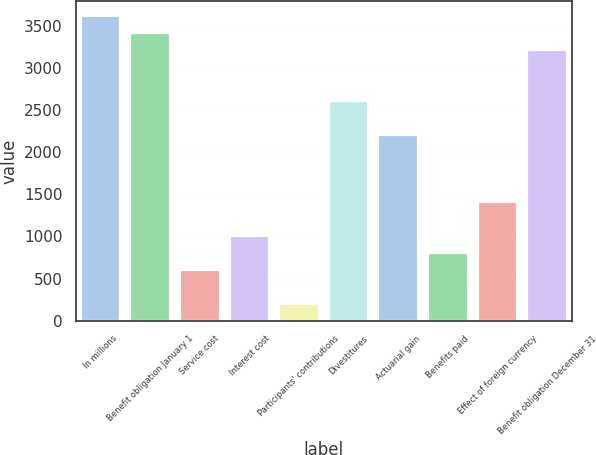Convert chart. <chart><loc_0><loc_0><loc_500><loc_500><bar_chart><fcel>In millions<fcel>Benefit obligation January 1<fcel>Service cost<fcel>Interest cost<fcel>Participants' contributions<fcel>Divestitures<fcel>Actuarial gain<fcel>Benefits paid<fcel>Effect of foreign currency<fcel>Benefit obligation December 31<nl><fcel>3611.8<fcel>3411.2<fcel>602.8<fcel>1004<fcel>201.6<fcel>2608.8<fcel>2207.6<fcel>803.4<fcel>1405.2<fcel>3210.6<nl></chart> 